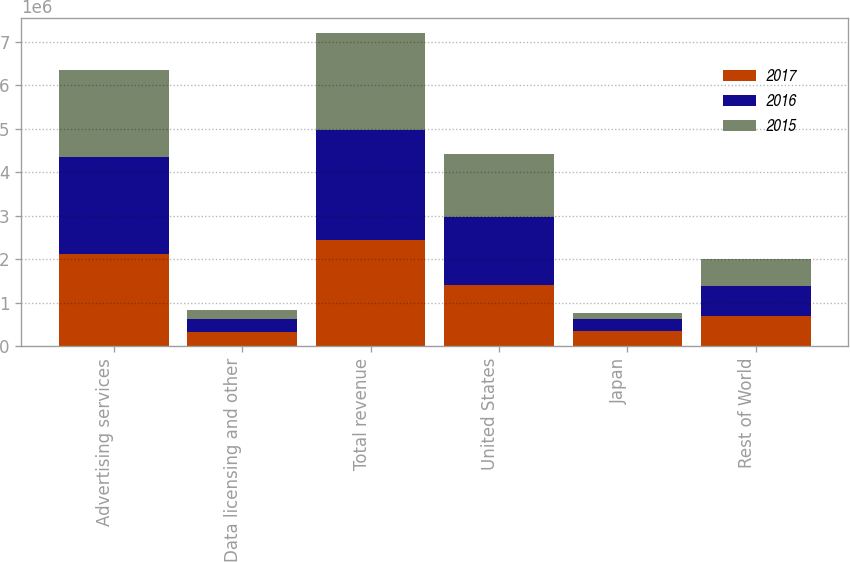Convert chart to OTSL. <chart><loc_0><loc_0><loc_500><loc_500><stacked_bar_chart><ecel><fcel>Advertising services<fcel>Data licensing and other<fcel>Total revenue<fcel>United States<fcel>Japan<fcel>Rest of World<nl><fcel>2017<fcel>2.10999e+06<fcel>333312<fcel>2.4433e+06<fcel>1.41361e+06<fcel>343741<fcel>685944<nl><fcel>2016<fcel>2.24805e+06<fcel>281567<fcel>2.52962e+06<fcel>1.56478e+06<fcel>268496<fcel>696347<nl><fcel>2015<fcel>1.99404e+06<fcel>223996<fcel>2.21803e+06<fcel>1.44324e+06<fcel>147713<fcel>627079<nl></chart> 